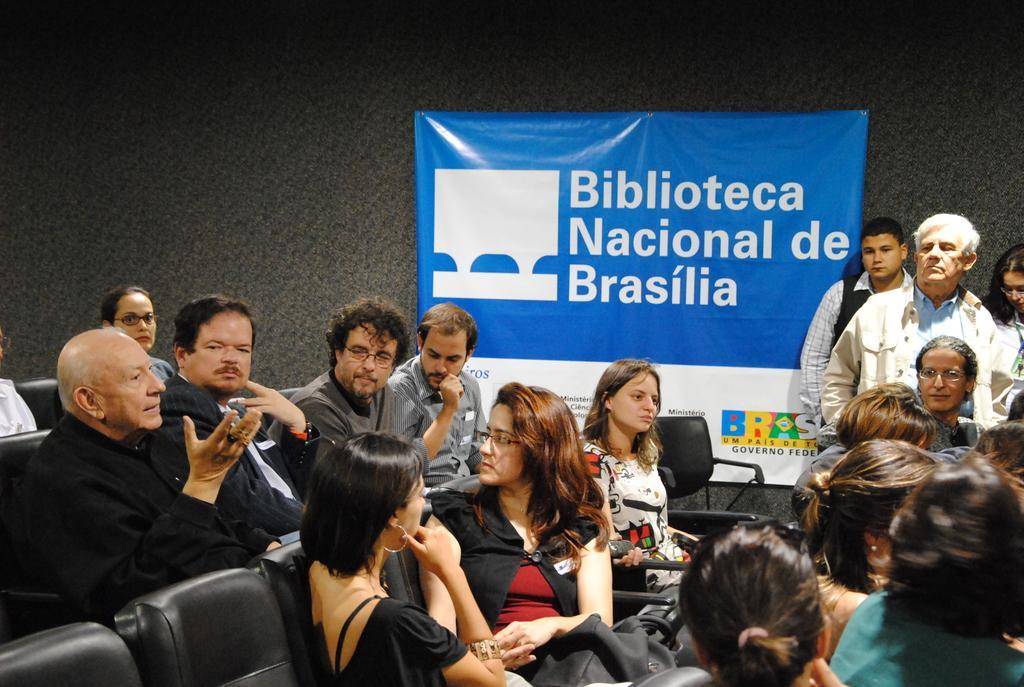How would you summarize this image in a sentence or two? This picture is taken inside the room. In this image, we can see a group of people sitting on the chair. On the right side, we can see three people are standing. In the background, we can see a hoarding which is attached to a black color wall. 